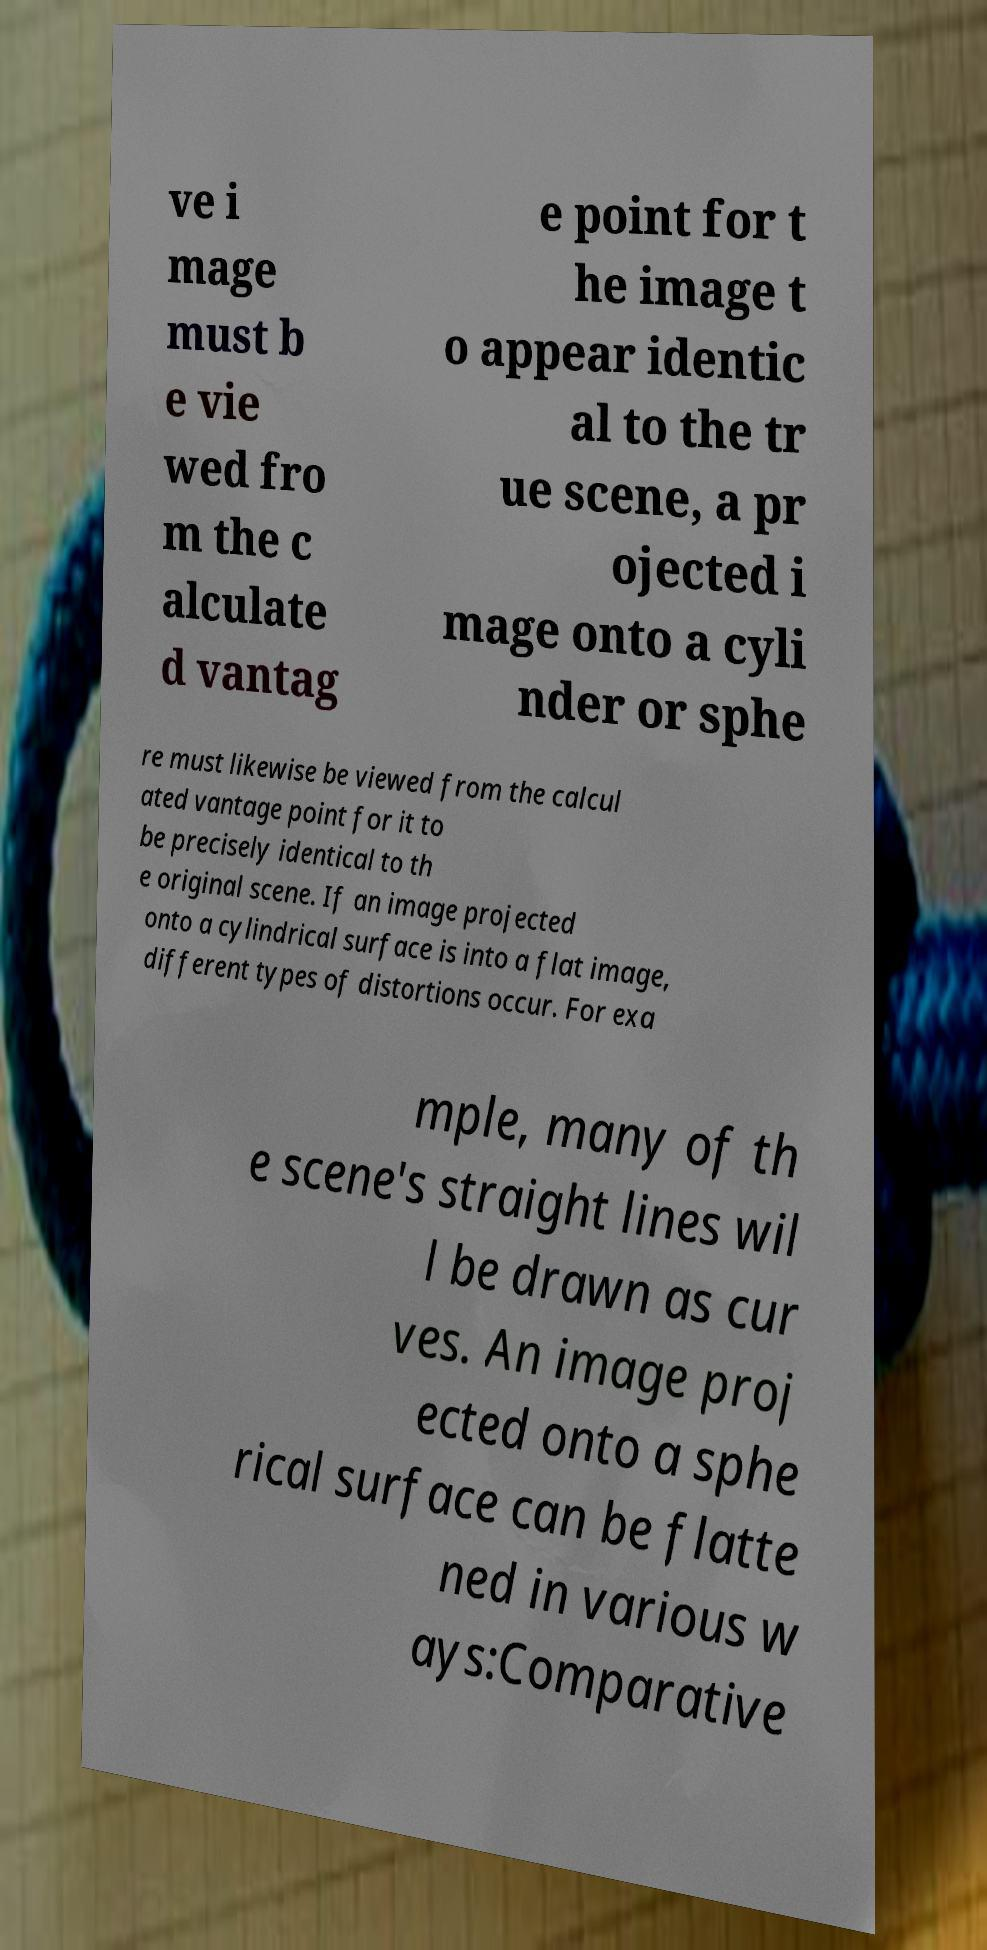Could you extract and type out the text from this image? ve i mage must b e vie wed fro m the c alculate d vantag e point for t he image t o appear identic al to the tr ue scene, a pr ojected i mage onto a cyli nder or sphe re must likewise be viewed from the calcul ated vantage point for it to be precisely identical to th e original scene. If an image projected onto a cylindrical surface is into a flat image, different types of distortions occur. For exa mple, many of th e scene's straight lines wil l be drawn as cur ves. An image proj ected onto a sphe rical surface can be flatte ned in various w ays:Comparative 